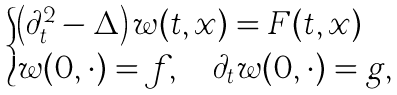<formula> <loc_0><loc_0><loc_500><loc_500>\begin{cases} \left ( \partial ^ { 2 } _ { t } - \Delta \right ) w ( t , x ) = F ( t , x ) \\ w ( 0 , \cdot ) = f , \quad \partial _ { t } w ( 0 , \cdot ) = g , \end{cases}</formula> 